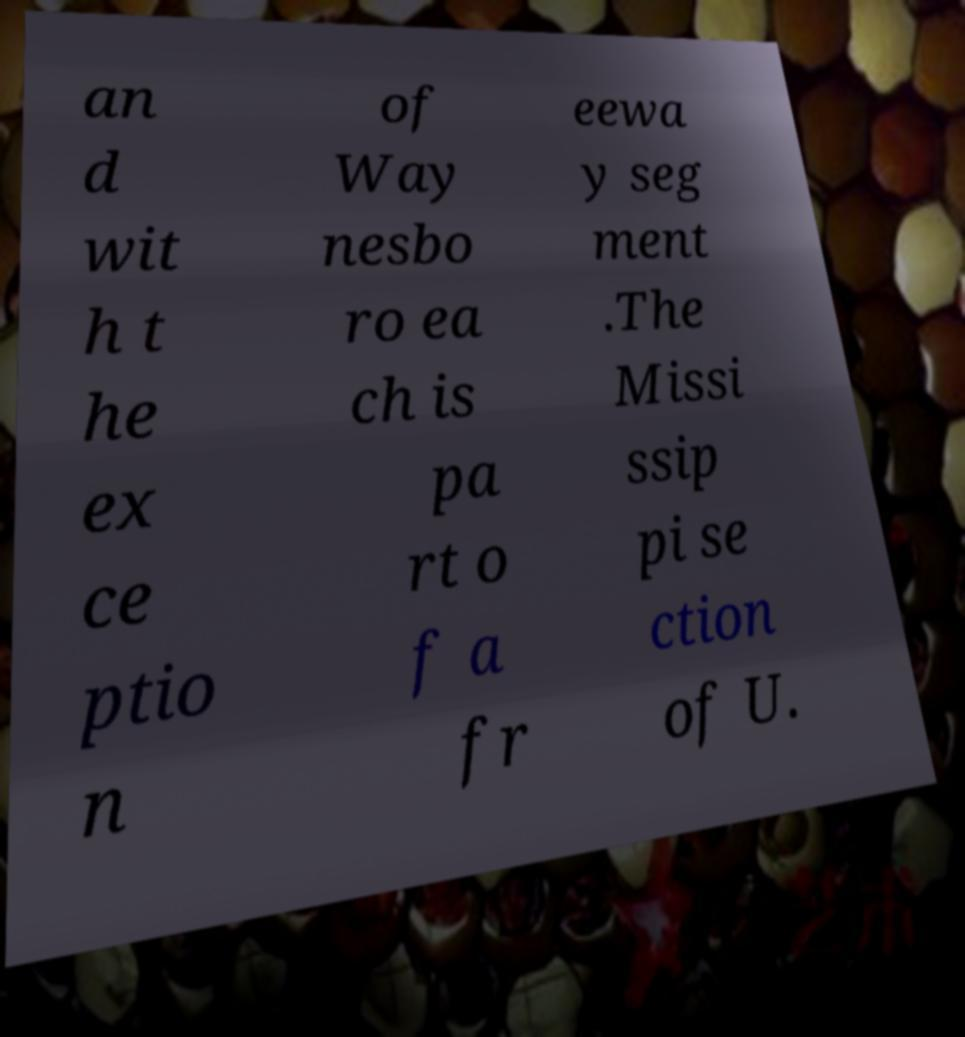Could you assist in decoding the text presented in this image and type it out clearly? an d wit h t he ex ce ptio n of Way nesbo ro ea ch is pa rt o f a fr eewa y seg ment .The Missi ssip pi se ction of U. 